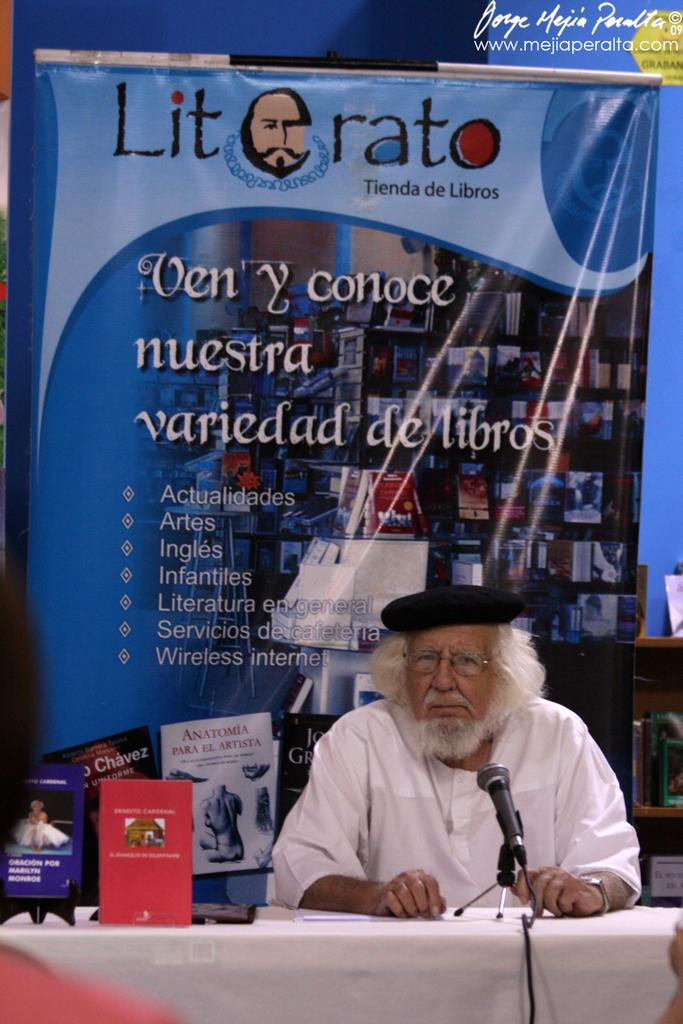What is the man in the image doing? The man is sitting in the image. Can you describe what the man is wearing? The man is wearing a cap. What is in front of the man? There is a table in front of the man. What is on the table? There are boards and a mic on the table. What can be seen in the background of the image? There is a banner in the background of the image. What type of gold is the man holding in the image? There is no gold present in the image. Can you tell me the story behind the basket in the image? There is no basket present in the image. 